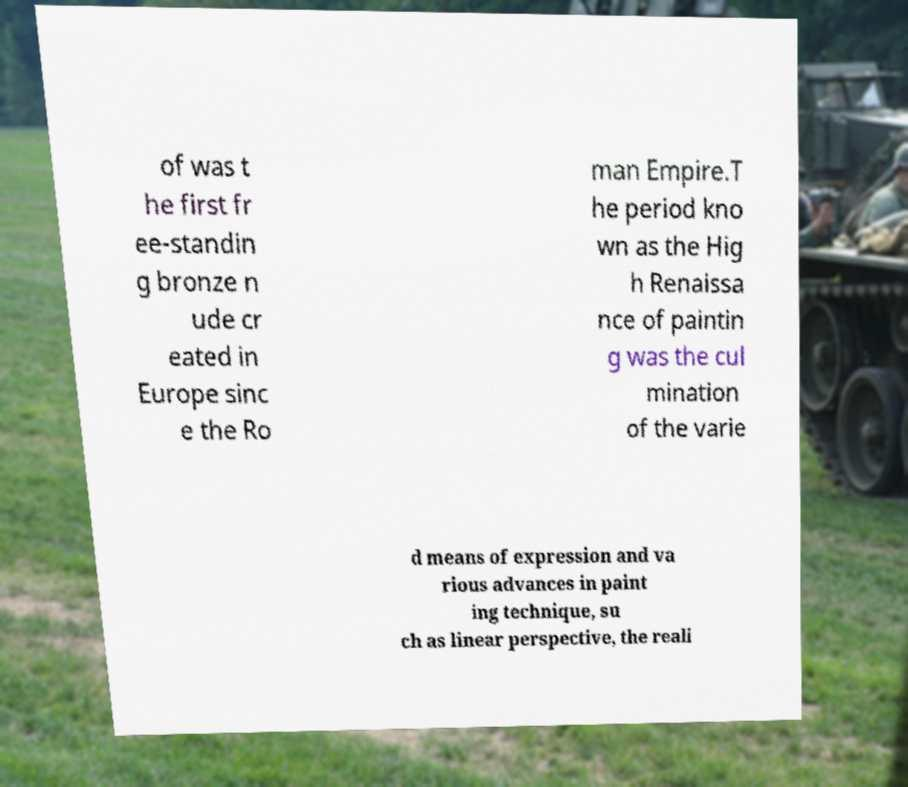There's text embedded in this image that I need extracted. Can you transcribe it verbatim? of was t he first fr ee-standin g bronze n ude cr eated in Europe sinc e the Ro man Empire.T he period kno wn as the Hig h Renaissa nce of paintin g was the cul mination of the varie d means of expression and va rious advances in paint ing technique, su ch as linear perspective, the reali 